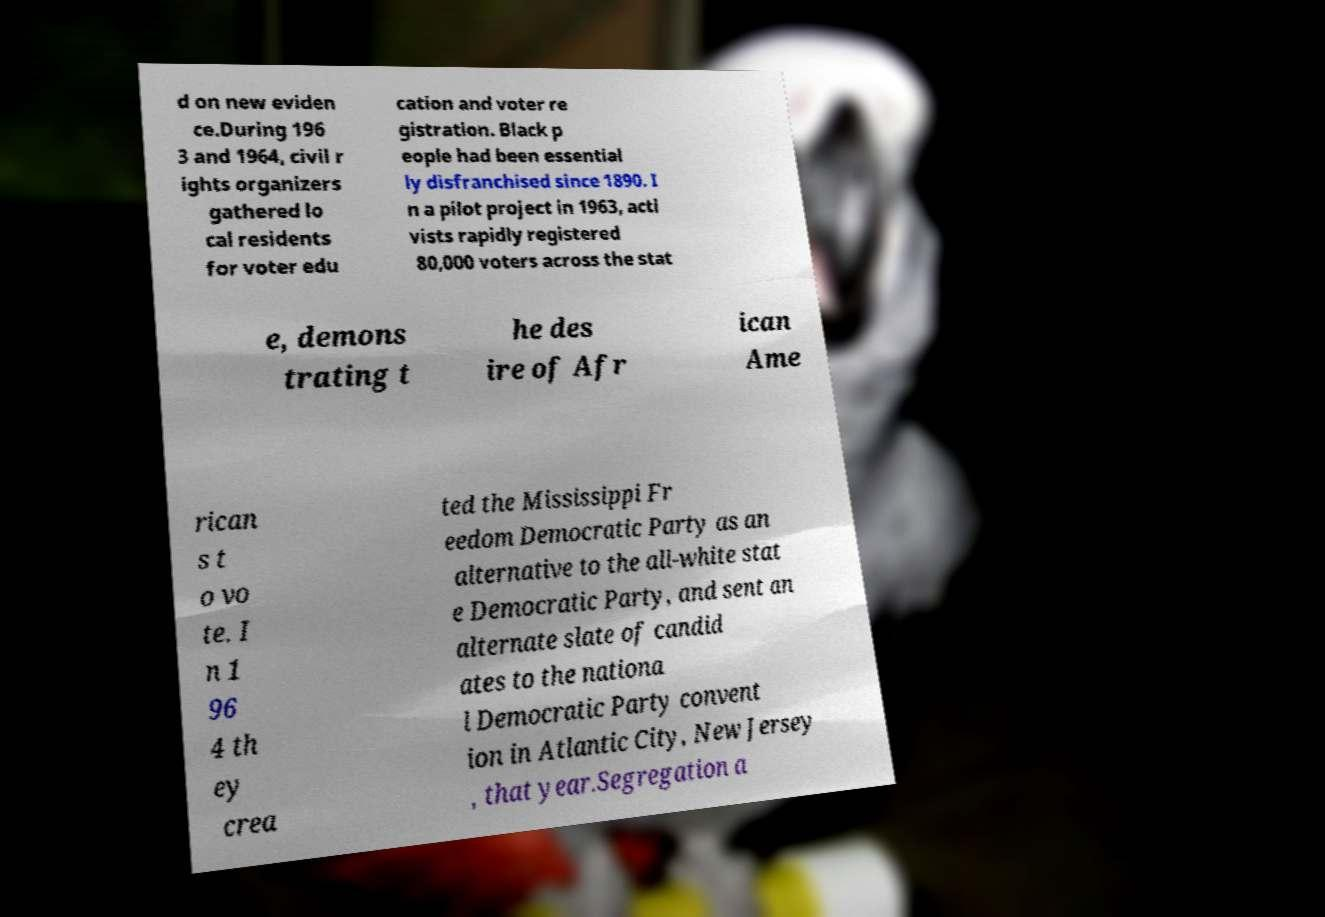Can you read and provide the text displayed in the image?This photo seems to have some interesting text. Can you extract and type it out for me? d on new eviden ce.During 196 3 and 1964, civil r ights organizers gathered lo cal residents for voter edu cation and voter re gistration. Black p eople had been essential ly disfranchised since 1890. I n a pilot project in 1963, acti vists rapidly registered 80,000 voters across the stat e, demons trating t he des ire of Afr ican Ame rican s t o vo te. I n 1 96 4 th ey crea ted the Mississippi Fr eedom Democratic Party as an alternative to the all-white stat e Democratic Party, and sent an alternate slate of candid ates to the nationa l Democratic Party convent ion in Atlantic City, New Jersey , that year.Segregation a 